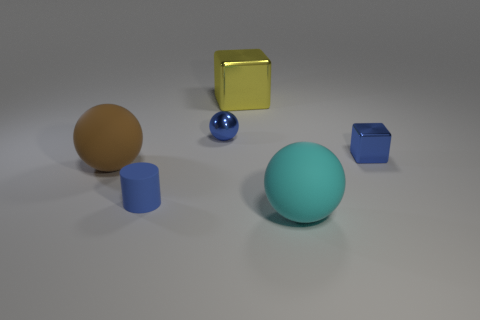How many large things are purple metallic things or blue balls?
Ensure brevity in your answer.  0. Are there any other things that have the same shape as the cyan object?
Provide a short and direct response. Yes. Are there any other things that have the same size as the matte cylinder?
Your response must be concise. Yes. The small object that is the same material as the blue block is what color?
Offer a terse response. Blue. There is a big rubber ball behind the tiny blue rubber cylinder; what color is it?
Provide a succinct answer. Brown. What number of big metallic things are the same color as the small matte cylinder?
Your answer should be compact. 0. Are there fewer large yellow metallic things that are in front of the brown rubber thing than blue spheres that are right of the small ball?
Your answer should be compact. No. There is a large cyan rubber ball; how many metal things are to the right of it?
Your answer should be compact. 1. Are there any tiny cylinders that have the same material as the brown thing?
Your response must be concise. Yes. Are there more big brown objects to the left of the large brown matte object than big objects to the left of the big yellow block?
Give a very brief answer. No. 